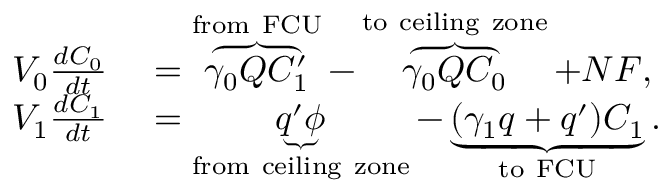Convert formula to latex. <formula><loc_0><loc_0><loc_500><loc_500>\begin{array} { r l } { V _ { 0 } \frac { d C _ { 0 } } { d t } } & = \overbrace { \gamma _ { 0 } Q C _ { 1 } ^ { \prime } } ^ { f r o m \ F C U } - \overbrace { \gamma _ { 0 } Q C _ { 0 } } ^ { t o \ c e i l i n g \ z o n e } + N F , } \\ { V _ { 1 } \frac { d C _ { 1 } } { d t } } & = \underbrace { q ^ { \prime } \phi } _ { f r o m \ c e i l i n g \ z o n e } - \underbrace { ( \gamma _ { 1 } q + q ^ { \prime } ) C _ { 1 } } _ { t o \ F C U } . } \end{array}</formula> 